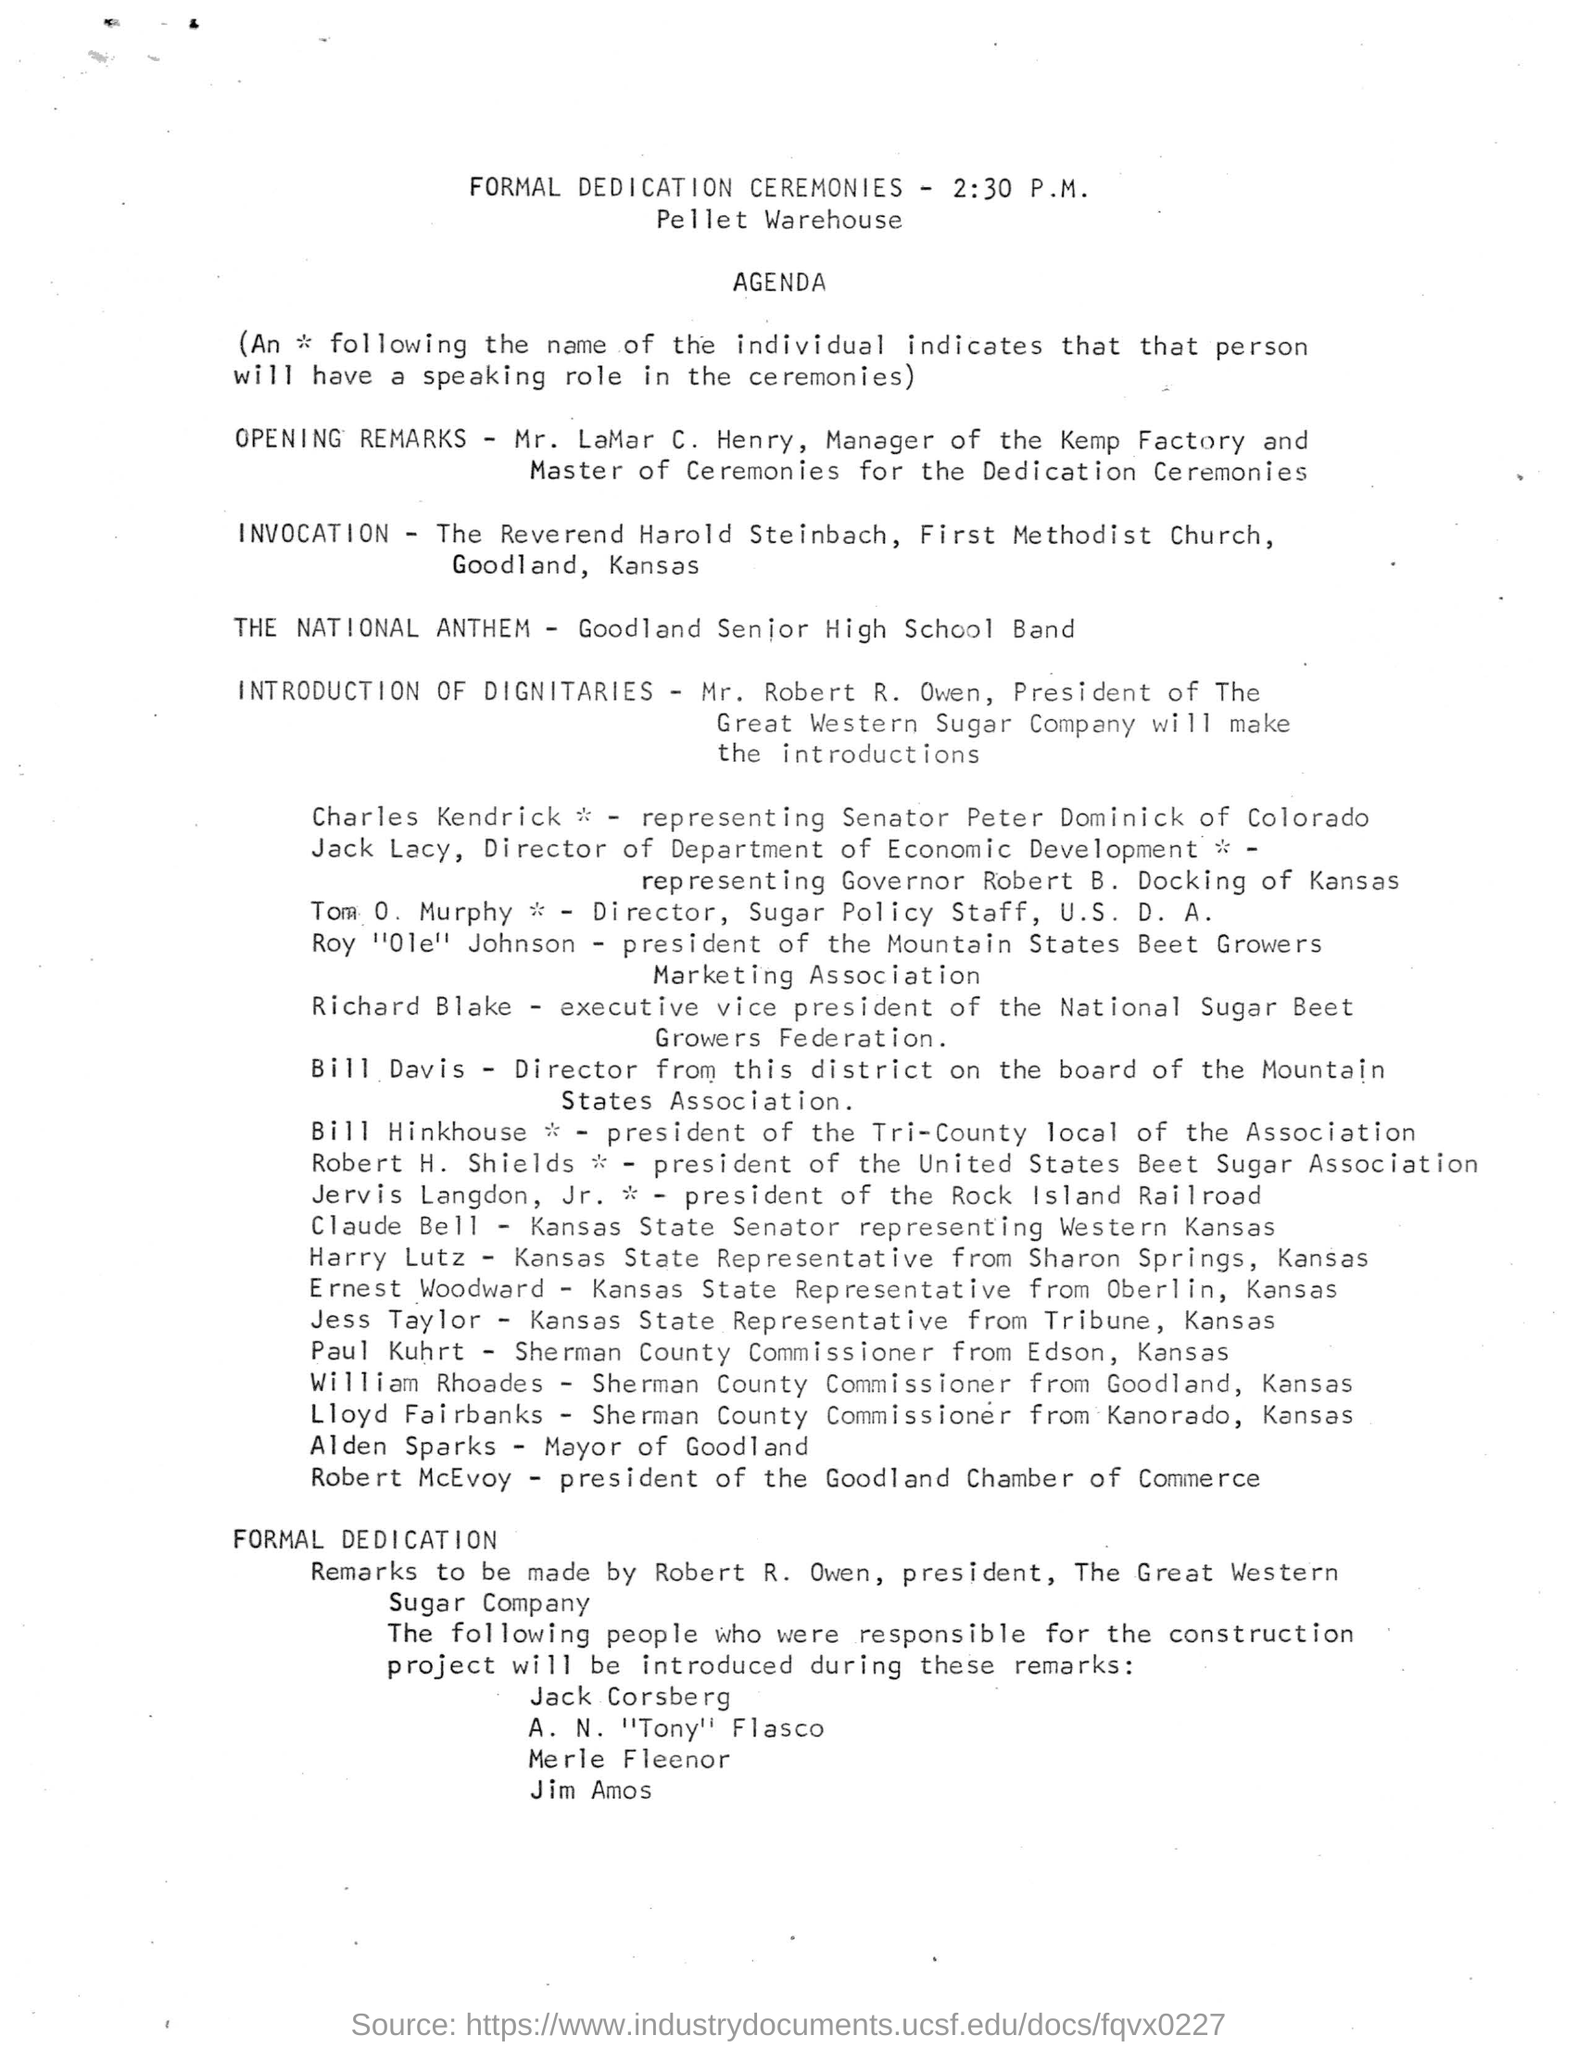Specify some key components in this picture. Tom O. Murphy's designation is Director of the Sugar Policy Staff at the U.S. Department of Agriculture. Robert R. Owen will be giving the introduction of dignitaries as per the agenda. The formal dedication ceremonies will be held at 2:30 PM. Mr. Robert R. Owen is designated as the President. It has been announced that Charles Kendrick is representing Senator Peter Dominick of Colorado at the upcoming agenda. 